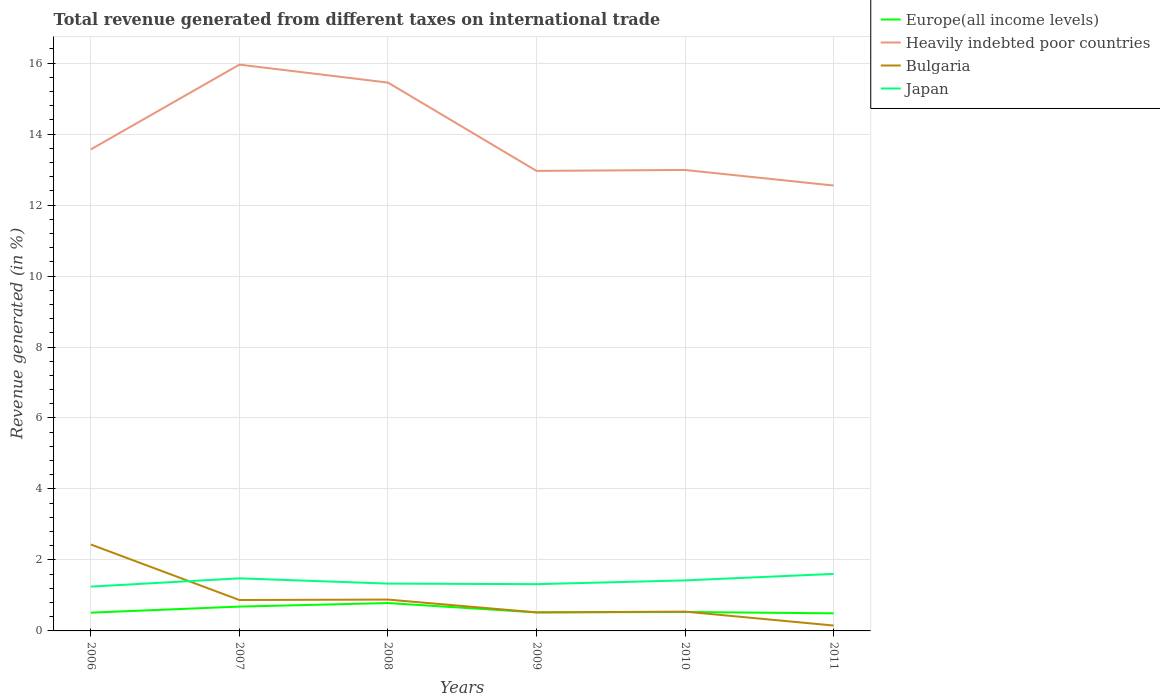Does the line corresponding to Heavily indebted poor countries intersect with the line corresponding to Japan?
Make the answer very short. No. Is the number of lines equal to the number of legend labels?
Offer a very short reply. Yes. Across all years, what is the maximum total revenue generated in Bulgaria?
Your response must be concise. 0.15. In which year was the total revenue generated in Europe(all income levels) maximum?
Provide a short and direct response. 2011. What is the total total revenue generated in Japan in the graph?
Offer a very short reply. -0.29. What is the difference between the highest and the second highest total revenue generated in Heavily indebted poor countries?
Ensure brevity in your answer.  3.41. How many lines are there?
Give a very brief answer. 4. What is the difference between two consecutive major ticks on the Y-axis?
Ensure brevity in your answer.  2. Does the graph contain grids?
Your answer should be very brief. Yes. How many legend labels are there?
Keep it short and to the point. 4. What is the title of the graph?
Provide a succinct answer. Total revenue generated from different taxes on international trade. What is the label or title of the X-axis?
Keep it short and to the point. Years. What is the label or title of the Y-axis?
Your answer should be compact. Revenue generated (in %). What is the Revenue generated (in %) of Europe(all income levels) in 2006?
Provide a short and direct response. 0.51. What is the Revenue generated (in %) in Heavily indebted poor countries in 2006?
Give a very brief answer. 13.57. What is the Revenue generated (in %) in Bulgaria in 2006?
Provide a succinct answer. 2.44. What is the Revenue generated (in %) of Japan in 2006?
Make the answer very short. 1.25. What is the Revenue generated (in %) in Europe(all income levels) in 2007?
Your answer should be compact. 0.69. What is the Revenue generated (in %) in Heavily indebted poor countries in 2007?
Keep it short and to the point. 15.96. What is the Revenue generated (in %) in Bulgaria in 2007?
Give a very brief answer. 0.87. What is the Revenue generated (in %) of Japan in 2007?
Offer a terse response. 1.48. What is the Revenue generated (in %) in Europe(all income levels) in 2008?
Make the answer very short. 0.79. What is the Revenue generated (in %) in Heavily indebted poor countries in 2008?
Your answer should be compact. 15.45. What is the Revenue generated (in %) of Bulgaria in 2008?
Offer a very short reply. 0.88. What is the Revenue generated (in %) of Japan in 2008?
Your response must be concise. 1.33. What is the Revenue generated (in %) of Europe(all income levels) in 2009?
Offer a very short reply. 0.52. What is the Revenue generated (in %) in Heavily indebted poor countries in 2009?
Your response must be concise. 12.96. What is the Revenue generated (in %) of Bulgaria in 2009?
Your answer should be very brief. 0.52. What is the Revenue generated (in %) in Japan in 2009?
Offer a terse response. 1.32. What is the Revenue generated (in %) in Europe(all income levels) in 2010?
Offer a very short reply. 0.53. What is the Revenue generated (in %) of Heavily indebted poor countries in 2010?
Offer a very short reply. 12.99. What is the Revenue generated (in %) in Bulgaria in 2010?
Offer a very short reply. 0.54. What is the Revenue generated (in %) of Japan in 2010?
Give a very brief answer. 1.42. What is the Revenue generated (in %) in Europe(all income levels) in 2011?
Offer a very short reply. 0.5. What is the Revenue generated (in %) in Heavily indebted poor countries in 2011?
Offer a terse response. 12.55. What is the Revenue generated (in %) in Bulgaria in 2011?
Make the answer very short. 0.15. What is the Revenue generated (in %) of Japan in 2011?
Your answer should be compact. 1.61. Across all years, what is the maximum Revenue generated (in %) of Europe(all income levels)?
Offer a very short reply. 0.79. Across all years, what is the maximum Revenue generated (in %) in Heavily indebted poor countries?
Provide a short and direct response. 15.96. Across all years, what is the maximum Revenue generated (in %) of Bulgaria?
Provide a short and direct response. 2.44. Across all years, what is the maximum Revenue generated (in %) of Japan?
Offer a very short reply. 1.61. Across all years, what is the minimum Revenue generated (in %) of Europe(all income levels)?
Offer a terse response. 0.5. Across all years, what is the minimum Revenue generated (in %) of Heavily indebted poor countries?
Your answer should be very brief. 12.55. Across all years, what is the minimum Revenue generated (in %) in Bulgaria?
Keep it short and to the point. 0.15. Across all years, what is the minimum Revenue generated (in %) of Japan?
Your answer should be very brief. 1.25. What is the total Revenue generated (in %) in Europe(all income levels) in the graph?
Keep it short and to the point. 3.54. What is the total Revenue generated (in %) in Heavily indebted poor countries in the graph?
Your response must be concise. 83.48. What is the total Revenue generated (in %) in Bulgaria in the graph?
Your answer should be very brief. 5.41. What is the total Revenue generated (in %) of Japan in the graph?
Offer a very short reply. 8.41. What is the difference between the Revenue generated (in %) of Europe(all income levels) in 2006 and that in 2007?
Offer a terse response. -0.17. What is the difference between the Revenue generated (in %) of Heavily indebted poor countries in 2006 and that in 2007?
Ensure brevity in your answer.  -2.39. What is the difference between the Revenue generated (in %) of Bulgaria in 2006 and that in 2007?
Ensure brevity in your answer.  1.56. What is the difference between the Revenue generated (in %) of Japan in 2006 and that in 2007?
Ensure brevity in your answer.  -0.23. What is the difference between the Revenue generated (in %) in Europe(all income levels) in 2006 and that in 2008?
Offer a terse response. -0.27. What is the difference between the Revenue generated (in %) of Heavily indebted poor countries in 2006 and that in 2008?
Make the answer very short. -1.88. What is the difference between the Revenue generated (in %) in Bulgaria in 2006 and that in 2008?
Your answer should be compact. 1.55. What is the difference between the Revenue generated (in %) in Japan in 2006 and that in 2008?
Offer a very short reply. -0.09. What is the difference between the Revenue generated (in %) of Europe(all income levels) in 2006 and that in 2009?
Provide a short and direct response. -0.01. What is the difference between the Revenue generated (in %) in Heavily indebted poor countries in 2006 and that in 2009?
Give a very brief answer. 0.61. What is the difference between the Revenue generated (in %) of Bulgaria in 2006 and that in 2009?
Make the answer very short. 1.91. What is the difference between the Revenue generated (in %) in Japan in 2006 and that in 2009?
Keep it short and to the point. -0.07. What is the difference between the Revenue generated (in %) in Europe(all income levels) in 2006 and that in 2010?
Your response must be concise. -0.02. What is the difference between the Revenue generated (in %) of Heavily indebted poor countries in 2006 and that in 2010?
Give a very brief answer. 0.58. What is the difference between the Revenue generated (in %) in Bulgaria in 2006 and that in 2010?
Offer a terse response. 1.89. What is the difference between the Revenue generated (in %) in Japan in 2006 and that in 2010?
Your answer should be compact. -0.18. What is the difference between the Revenue generated (in %) of Europe(all income levels) in 2006 and that in 2011?
Your response must be concise. 0.02. What is the difference between the Revenue generated (in %) of Heavily indebted poor countries in 2006 and that in 2011?
Provide a succinct answer. 1.02. What is the difference between the Revenue generated (in %) of Bulgaria in 2006 and that in 2011?
Ensure brevity in your answer.  2.28. What is the difference between the Revenue generated (in %) in Japan in 2006 and that in 2011?
Make the answer very short. -0.36. What is the difference between the Revenue generated (in %) in Europe(all income levels) in 2007 and that in 2008?
Provide a succinct answer. -0.1. What is the difference between the Revenue generated (in %) in Heavily indebted poor countries in 2007 and that in 2008?
Provide a succinct answer. 0.51. What is the difference between the Revenue generated (in %) of Bulgaria in 2007 and that in 2008?
Give a very brief answer. -0.01. What is the difference between the Revenue generated (in %) in Japan in 2007 and that in 2008?
Provide a short and direct response. 0.15. What is the difference between the Revenue generated (in %) in Europe(all income levels) in 2007 and that in 2009?
Give a very brief answer. 0.16. What is the difference between the Revenue generated (in %) of Heavily indebted poor countries in 2007 and that in 2009?
Provide a short and direct response. 2.99. What is the difference between the Revenue generated (in %) in Bulgaria in 2007 and that in 2009?
Your response must be concise. 0.35. What is the difference between the Revenue generated (in %) of Japan in 2007 and that in 2009?
Give a very brief answer. 0.16. What is the difference between the Revenue generated (in %) of Europe(all income levels) in 2007 and that in 2010?
Ensure brevity in your answer.  0.15. What is the difference between the Revenue generated (in %) of Heavily indebted poor countries in 2007 and that in 2010?
Your response must be concise. 2.97. What is the difference between the Revenue generated (in %) of Bulgaria in 2007 and that in 2010?
Offer a terse response. 0.33. What is the difference between the Revenue generated (in %) in Japan in 2007 and that in 2010?
Ensure brevity in your answer.  0.06. What is the difference between the Revenue generated (in %) of Europe(all income levels) in 2007 and that in 2011?
Your answer should be very brief. 0.19. What is the difference between the Revenue generated (in %) of Heavily indebted poor countries in 2007 and that in 2011?
Make the answer very short. 3.41. What is the difference between the Revenue generated (in %) in Bulgaria in 2007 and that in 2011?
Your answer should be very brief. 0.72. What is the difference between the Revenue generated (in %) of Japan in 2007 and that in 2011?
Offer a very short reply. -0.12. What is the difference between the Revenue generated (in %) of Europe(all income levels) in 2008 and that in 2009?
Give a very brief answer. 0.26. What is the difference between the Revenue generated (in %) in Heavily indebted poor countries in 2008 and that in 2009?
Give a very brief answer. 2.49. What is the difference between the Revenue generated (in %) in Bulgaria in 2008 and that in 2009?
Your response must be concise. 0.36. What is the difference between the Revenue generated (in %) in Japan in 2008 and that in 2009?
Your response must be concise. 0.02. What is the difference between the Revenue generated (in %) of Europe(all income levels) in 2008 and that in 2010?
Your answer should be compact. 0.25. What is the difference between the Revenue generated (in %) of Heavily indebted poor countries in 2008 and that in 2010?
Provide a short and direct response. 2.46. What is the difference between the Revenue generated (in %) in Bulgaria in 2008 and that in 2010?
Ensure brevity in your answer.  0.34. What is the difference between the Revenue generated (in %) in Japan in 2008 and that in 2010?
Provide a succinct answer. -0.09. What is the difference between the Revenue generated (in %) of Europe(all income levels) in 2008 and that in 2011?
Provide a short and direct response. 0.29. What is the difference between the Revenue generated (in %) of Heavily indebted poor countries in 2008 and that in 2011?
Your answer should be compact. 2.9. What is the difference between the Revenue generated (in %) of Bulgaria in 2008 and that in 2011?
Give a very brief answer. 0.73. What is the difference between the Revenue generated (in %) of Japan in 2008 and that in 2011?
Provide a short and direct response. -0.27. What is the difference between the Revenue generated (in %) in Europe(all income levels) in 2009 and that in 2010?
Give a very brief answer. -0.01. What is the difference between the Revenue generated (in %) of Heavily indebted poor countries in 2009 and that in 2010?
Provide a short and direct response. -0.03. What is the difference between the Revenue generated (in %) of Bulgaria in 2009 and that in 2010?
Offer a terse response. -0.02. What is the difference between the Revenue generated (in %) in Japan in 2009 and that in 2010?
Your answer should be very brief. -0.11. What is the difference between the Revenue generated (in %) of Europe(all income levels) in 2009 and that in 2011?
Your response must be concise. 0.03. What is the difference between the Revenue generated (in %) of Heavily indebted poor countries in 2009 and that in 2011?
Keep it short and to the point. 0.41. What is the difference between the Revenue generated (in %) of Bulgaria in 2009 and that in 2011?
Provide a succinct answer. 0.37. What is the difference between the Revenue generated (in %) of Japan in 2009 and that in 2011?
Ensure brevity in your answer.  -0.29. What is the difference between the Revenue generated (in %) in Europe(all income levels) in 2010 and that in 2011?
Your answer should be compact. 0.04. What is the difference between the Revenue generated (in %) of Heavily indebted poor countries in 2010 and that in 2011?
Offer a very short reply. 0.44. What is the difference between the Revenue generated (in %) of Bulgaria in 2010 and that in 2011?
Make the answer very short. 0.39. What is the difference between the Revenue generated (in %) of Japan in 2010 and that in 2011?
Your answer should be compact. -0.18. What is the difference between the Revenue generated (in %) of Europe(all income levels) in 2006 and the Revenue generated (in %) of Heavily indebted poor countries in 2007?
Make the answer very short. -15.44. What is the difference between the Revenue generated (in %) in Europe(all income levels) in 2006 and the Revenue generated (in %) in Bulgaria in 2007?
Give a very brief answer. -0.36. What is the difference between the Revenue generated (in %) of Europe(all income levels) in 2006 and the Revenue generated (in %) of Japan in 2007?
Provide a short and direct response. -0.97. What is the difference between the Revenue generated (in %) in Heavily indebted poor countries in 2006 and the Revenue generated (in %) in Bulgaria in 2007?
Offer a very short reply. 12.7. What is the difference between the Revenue generated (in %) of Heavily indebted poor countries in 2006 and the Revenue generated (in %) of Japan in 2007?
Make the answer very short. 12.09. What is the difference between the Revenue generated (in %) of Bulgaria in 2006 and the Revenue generated (in %) of Japan in 2007?
Make the answer very short. 0.95. What is the difference between the Revenue generated (in %) in Europe(all income levels) in 2006 and the Revenue generated (in %) in Heavily indebted poor countries in 2008?
Offer a very short reply. -14.94. What is the difference between the Revenue generated (in %) in Europe(all income levels) in 2006 and the Revenue generated (in %) in Bulgaria in 2008?
Provide a succinct answer. -0.37. What is the difference between the Revenue generated (in %) in Europe(all income levels) in 2006 and the Revenue generated (in %) in Japan in 2008?
Ensure brevity in your answer.  -0.82. What is the difference between the Revenue generated (in %) in Heavily indebted poor countries in 2006 and the Revenue generated (in %) in Bulgaria in 2008?
Keep it short and to the point. 12.69. What is the difference between the Revenue generated (in %) of Heavily indebted poor countries in 2006 and the Revenue generated (in %) of Japan in 2008?
Provide a short and direct response. 12.23. What is the difference between the Revenue generated (in %) in Bulgaria in 2006 and the Revenue generated (in %) in Japan in 2008?
Ensure brevity in your answer.  1.1. What is the difference between the Revenue generated (in %) in Europe(all income levels) in 2006 and the Revenue generated (in %) in Heavily indebted poor countries in 2009?
Provide a succinct answer. -12.45. What is the difference between the Revenue generated (in %) in Europe(all income levels) in 2006 and the Revenue generated (in %) in Bulgaria in 2009?
Ensure brevity in your answer.  -0.01. What is the difference between the Revenue generated (in %) of Europe(all income levels) in 2006 and the Revenue generated (in %) of Japan in 2009?
Your answer should be compact. -0.8. What is the difference between the Revenue generated (in %) in Heavily indebted poor countries in 2006 and the Revenue generated (in %) in Bulgaria in 2009?
Give a very brief answer. 13.05. What is the difference between the Revenue generated (in %) in Heavily indebted poor countries in 2006 and the Revenue generated (in %) in Japan in 2009?
Offer a very short reply. 12.25. What is the difference between the Revenue generated (in %) of Bulgaria in 2006 and the Revenue generated (in %) of Japan in 2009?
Provide a short and direct response. 1.12. What is the difference between the Revenue generated (in %) of Europe(all income levels) in 2006 and the Revenue generated (in %) of Heavily indebted poor countries in 2010?
Offer a terse response. -12.47. What is the difference between the Revenue generated (in %) of Europe(all income levels) in 2006 and the Revenue generated (in %) of Bulgaria in 2010?
Your answer should be very brief. -0.03. What is the difference between the Revenue generated (in %) of Europe(all income levels) in 2006 and the Revenue generated (in %) of Japan in 2010?
Offer a very short reply. -0.91. What is the difference between the Revenue generated (in %) of Heavily indebted poor countries in 2006 and the Revenue generated (in %) of Bulgaria in 2010?
Keep it short and to the point. 13.02. What is the difference between the Revenue generated (in %) of Heavily indebted poor countries in 2006 and the Revenue generated (in %) of Japan in 2010?
Your answer should be compact. 12.14. What is the difference between the Revenue generated (in %) of Bulgaria in 2006 and the Revenue generated (in %) of Japan in 2010?
Provide a short and direct response. 1.01. What is the difference between the Revenue generated (in %) of Europe(all income levels) in 2006 and the Revenue generated (in %) of Heavily indebted poor countries in 2011?
Your answer should be compact. -12.04. What is the difference between the Revenue generated (in %) in Europe(all income levels) in 2006 and the Revenue generated (in %) in Bulgaria in 2011?
Give a very brief answer. 0.36. What is the difference between the Revenue generated (in %) of Europe(all income levels) in 2006 and the Revenue generated (in %) of Japan in 2011?
Make the answer very short. -1.09. What is the difference between the Revenue generated (in %) in Heavily indebted poor countries in 2006 and the Revenue generated (in %) in Bulgaria in 2011?
Offer a very short reply. 13.42. What is the difference between the Revenue generated (in %) in Heavily indebted poor countries in 2006 and the Revenue generated (in %) in Japan in 2011?
Provide a succinct answer. 11.96. What is the difference between the Revenue generated (in %) in Bulgaria in 2006 and the Revenue generated (in %) in Japan in 2011?
Offer a terse response. 0.83. What is the difference between the Revenue generated (in %) in Europe(all income levels) in 2007 and the Revenue generated (in %) in Heavily indebted poor countries in 2008?
Make the answer very short. -14.77. What is the difference between the Revenue generated (in %) of Europe(all income levels) in 2007 and the Revenue generated (in %) of Bulgaria in 2008?
Your response must be concise. -0.2. What is the difference between the Revenue generated (in %) of Europe(all income levels) in 2007 and the Revenue generated (in %) of Japan in 2008?
Provide a succinct answer. -0.65. What is the difference between the Revenue generated (in %) of Heavily indebted poor countries in 2007 and the Revenue generated (in %) of Bulgaria in 2008?
Give a very brief answer. 15.07. What is the difference between the Revenue generated (in %) in Heavily indebted poor countries in 2007 and the Revenue generated (in %) in Japan in 2008?
Ensure brevity in your answer.  14.62. What is the difference between the Revenue generated (in %) of Bulgaria in 2007 and the Revenue generated (in %) of Japan in 2008?
Offer a very short reply. -0.46. What is the difference between the Revenue generated (in %) in Europe(all income levels) in 2007 and the Revenue generated (in %) in Heavily indebted poor countries in 2009?
Your answer should be compact. -12.28. What is the difference between the Revenue generated (in %) in Europe(all income levels) in 2007 and the Revenue generated (in %) in Bulgaria in 2009?
Offer a terse response. 0.16. What is the difference between the Revenue generated (in %) in Europe(all income levels) in 2007 and the Revenue generated (in %) in Japan in 2009?
Ensure brevity in your answer.  -0.63. What is the difference between the Revenue generated (in %) in Heavily indebted poor countries in 2007 and the Revenue generated (in %) in Bulgaria in 2009?
Your response must be concise. 15.43. What is the difference between the Revenue generated (in %) of Heavily indebted poor countries in 2007 and the Revenue generated (in %) of Japan in 2009?
Provide a succinct answer. 14.64. What is the difference between the Revenue generated (in %) of Bulgaria in 2007 and the Revenue generated (in %) of Japan in 2009?
Your answer should be very brief. -0.45. What is the difference between the Revenue generated (in %) of Europe(all income levels) in 2007 and the Revenue generated (in %) of Heavily indebted poor countries in 2010?
Offer a very short reply. -12.3. What is the difference between the Revenue generated (in %) of Europe(all income levels) in 2007 and the Revenue generated (in %) of Bulgaria in 2010?
Your answer should be very brief. 0.14. What is the difference between the Revenue generated (in %) of Europe(all income levels) in 2007 and the Revenue generated (in %) of Japan in 2010?
Your response must be concise. -0.74. What is the difference between the Revenue generated (in %) of Heavily indebted poor countries in 2007 and the Revenue generated (in %) of Bulgaria in 2010?
Give a very brief answer. 15.41. What is the difference between the Revenue generated (in %) in Heavily indebted poor countries in 2007 and the Revenue generated (in %) in Japan in 2010?
Your answer should be very brief. 14.53. What is the difference between the Revenue generated (in %) of Bulgaria in 2007 and the Revenue generated (in %) of Japan in 2010?
Make the answer very short. -0.55. What is the difference between the Revenue generated (in %) in Europe(all income levels) in 2007 and the Revenue generated (in %) in Heavily indebted poor countries in 2011?
Offer a terse response. -11.86. What is the difference between the Revenue generated (in %) of Europe(all income levels) in 2007 and the Revenue generated (in %) of Bulgaria in 2011?
Your response must be concise. 0.53. What is the difference between the Revenue generated (in %) of Europe(all income levels) in 2007 and the Revenue generated (in %) of Japan in 2011?
Give a very brief answer. -0.92. What is the difference between the Revenue generated (in %) in Heavily indebted poor countries in 2007 and the Revenue generated (in %) in Bulgaria in 2011?
Make the answer very short. 15.81. What is the difference between the Revenue generated (in %) in Heavily indebted poor countries in 2007 and the Revenue generated (in %) in Japan in 2011?
Offer a very short reply. 14.35. What is the difference between the Revenue generated (in %) of Bulgaria in 2007 and the Revenue generated (in %) of Japan in 2011?
Your answer should be very brief. -0.74. What is the difference between the Revenue generated (in %) of Europe(all income levels) in 2008 and the Revenue generated (in %) of Heavily indebted poor countries in 2009?
Make the answer very short. -12.18. What is the difference between the Revenue generated (in %) of Europe(all income levels) in 2008 and the Revenue generated (in %) of Bulgaria in 2009?
Make the answer very short. 0.26. What is the difference between the Revenue generated (in %) of Europe(all income levels) in 2008 and the Revenue generated (in %) of Japan in 2009?
Your answer should be compact. -0.53. What is the difference between the Revenue generated (in %) of Heavily indebted poor countries in 2008 and the Revenue generated (in %) of Bulgaria in 2009?
Your answer should be compact. 14.93. What is the difference between the Revenue generated (in %) in Heavily indebted poor countries in 2008 and the Revenue generated (in %) in Japan in 2009?
Provide a succinct answer. 14.13. What is the difference between the Revenue generated (in %) of Bulgaria in 2008 and the Revenue generated (in %) of Japan in 2009?
Offer a very short reply. -0.43. What is the difference between the Revenue generated (in %) in Europe(all income levels) in 2008 and the Revenue generated (in %) in Heavily indebted poor countries in 2010?
Ensure brevity in your answer.  -12.2. What is the difference between the Revenue generated (in %) in Europe(all income levels) in 2008 and the Revenue generated (in %) in Bulgaria in 2010?
Your response must be concise. 0.24. What is the difference between the Revenue generated (in %) of Europe(all income levels) in 2008 and the Revenue generated (in %) of Japan in 2010?
Your answer should be very brief. -0.64. What is the difference between the Revenue generated (in %) of Heavily indebted poor countries in 2008 and the Revenue generated (in %) of Bulgaria in 2010?
Give a very brief answer. 14.91. What is the difference between the Revenue generated (in %) of Heavily indebted poor countries in 2008 and the Revenue generated (in %) of Japan in 2010?
Give a very brief answer. 14.03. What is the difference between the Revenue generated (in %) of Bulgaria in 2008 and the Revenue generated (in %) of Japan in 2010?
Keep it short and to the point. -0.54. What is the difference between the Revenue generated (in %) in Europe(all income levels) in 2008 and the Revenue generated (in %) in Heavily indebted poor countries in 2011?
Provide a succinct answer. -11.76. What is the difference between the Revenue generated (in %) of Europe(all income levels) in 2008 and the Revenue generated (in %) of Bulgaria in 2011?
Keep it short and to the point. 0.63. What is the difference between the Revenue generated (in %) in Europe(all income levels) in 2008 and the Revenue generated (in %) in Japan in 2011?
Keep it short and to the point. -0.82. What is the difference between the Revenue generated (in %) in Heavily indebted poor countries in 2008 and the Revenue generated (in %) in Bulgaria in 2011?
Make the answer very short. 15.3. What is the difference between the Revenue generated (in %) in Heavily indebted poor countries in 2008 and the Revenue generated (in %) in Japan in 2011?
Your answer should be very brief. 13.84. What is the difference between the Revenue generated (in %) of Bulgaria in 2008 and the Revenue generated (in %) of Japan in 2011?
Your response must be concise. -0.72. What is the difference between the Revenue generated (in %) in Europe(all income levels) in 2009 and the Revenue generated (in %) in Heavily indebted poor countries in 2010?
Your answer should be very brief. -12.47. What is the difference between the Revenue generated (in %) of Europe(all income levels) in 2009 and the Revenue generated (in %) of Bulgaria in 2010?
Your response must be concise. -0.02. What is the difference between the Revenue generated (in %) in Europe(all income levels) in 2009 and the Revenue generated (in %) in Japan in 2010?
Offer a very short reply. -0.9. What is the difference between the Revenue generated (in %) in Heavily indebted poor countries in 2009 and the Revenue generated (in %) in Bulgaria in 2010?
Keep it short and to the point. 12.42. What is the difference between the Revenue generated (in %) in Heavily indebted poor countries in 2009 and the Revenue generated (in %) in Japan in 2010?
Offer a terse response. 11.54. What is the difference between the Revenue generated (in %) in Bulgaria in 2009 and the Revenue generated (in %) in Japan in 2010?
Your answer should be compact. -0.9. What is the difference between the Revenue generated (in %) of Europe(all income levels) in 2009 and the Revenue generated (in %) of Heavily indebted poor countries in 2011?
Ensure brevity in your answer.  -12.03. What is the difference between the Revenue generated (in %) in Europe(all income levels) in 2009 and the Revenue generated (in %) in Bulgaria in 2011?
Give a very brief answer. 0.37. What is the difference between the Revenue generated (in %) in Europe(all income levels) in 2009 and the Revenue generated (in %) in Japan in 2011?
Ensure brevity in your answer.  -1.08. What is the difference between the Revenue generated (in %) in Heavily indebted poor countries in 2009 and the Revenue generated (in %) in Bulgaria in 2011?
Provide a succinct answer. 12.81. What is the difference between the Revenue generated (in %) in Heavily indebted poor countries in 2009 and the Revenue generated (in %) in Japan in 2011?
Keep it short and to the point. 11.36. What is the difference between the Revenue generated (in %) in Bulgaria in 2009 and the Revenue generated (in %) in Japan in 2011?
Your answer should be very brief. -1.08. What is the difference between the Revenue generated (in %) of Europe(all income levels) in 2010 and the Revenue generated (in %) of Heavily indebted poor countries in 2011?
Your response must be concise. -12.02. What is the difference between the Revenue generated (in %) in Europe(all income levels) in 2010 and the Revenue generated (in %) in Bulgaria in 2011?
Make the answer very short. 0.38. What is the difference between the Revenue generated (in %) of Europe(all income levels) in 2010 and the Revenue generated (in %) of Japan in 2011?
Offer a very short reply. -1.07. What is the difference between the Revenue generated (in %) in Heavily indebted poor countries in 2010 and the Revenue generated (in %) in Bulgaria in 2011?
Give a very brief answer. 12.84. What is the difference between the Revenue generated (in %) of Heavily indebted poor countries in 2010 and the Revenue generated (in %) of Japan in 2011?
Keep it short and to the point. 11.38. What is the difference between the Revenue generated (in %) of Bulgaria in 2010 and the Revenue generated (in %) of Japan in 2011?
Offer a terse response. -1.06. What is the average Revenue generated (in %) of Europe(all income levels) per year?
Provide a succinct answer. 0.59. What is the average Revenue generated (in %) of Heavily indebted poor countries per year?
Provide a short and direct response. 13.91. What is the average Revenue generated (in %) of Bulgaria per year?
Offer a very short reply. 0.9. What is the average Revenue generated (in %) in Japan per year?
Your response must be concise. 1.4. In the year 2006, what is the difference between the Revenue generated (in %) of Europe(all income levels) and Revenue generated (in %) of Heavily indebted poor countries?
Offer a terse response. -13.05. In the year 2006, what is the difference between the Revenue generated (in %) of Europe(all income levels) and Revenue generated (in %) of Bulgaria?
Give a very brief answer. -1.92. In the year 2006, what is the difference between the Revenue generated (in %) of Europe(all income levels) and Revenue generated (in %) of Japan?
Keep it short and to the point. -0.73. In the year 2006, what is the difference between the Revenue generated (in %) in Heavily indebted poor countries and Revenue generated (in %) in Bulgaria?
Provide a short and direct response. 11.13. In the year 2006, what is the difference between the Revenue generated (in %) of Heavily indebted poor countries and Revenue generated (in %) of Japan?
Your answer should be compact. 12.32. In the year 2006, what is the difference between the Revenue generated (in %) in Bulgaria and Revenue generated (in %) in Japan?
Ensure brevity in your answer.  1.19. In the year 2007, what is the difference between the Revenue generated (in %) of Europe(all income levels) and Revenue generated (in %) of Heavily indebted poor countries?
Give a very brief answer. -15.27. In the year 2007, what is the difference between the Revenue generated (in %) of Europe(all income levels) and Revenue generated (in %) of Bulgaria?
Keep it short and to the point. -0.19. In the year 2007, what is the difference between the Revenue generated (in %) of Europe(all income levels) and Revenue generated (in %) of Japan?
Ensure brevity in your answer.  -0.8. In the year 2007, what is the difference between the Revenue generated (in %) in Heavily indebted poor countries and Revenue generated (in %) in Bulgaria?
Your response must be concise. 15.09. In the year 2007, what is the difference between the Revenue generated (in %) of Heavily indebted poor countries and Revenue generated (in %) of Japan?
Your answer should be compact. 14.48. In the year 2007, what is the difference between the Revenue generated (in %) of Bulgaria and Revenue generated (in %) of Japan?
Give a very brief answer. -0.61. In the year 2008, what is the difference between the Revenue generated (in %) of Europe(all income levels) and Revenue generated (in %) of Heavily indebted poor countries?
Offer a very short reply. -14.67. In the year 2008, what is the difference between the Revenue generated (in %) of Europe(all income levels) and Revenue generated (in %) of Bulgaria?
Make the answer very short. -0.1. In the year 2008, what is the difference between the Revenue generated (in %) in Europe(all income levels) and Revenue generated (in %) in Japan?
Provide a short and direct response. -0.55. In the year 2008, what is the difference between the Revenue generated (in %) in Heavily indebted poor countries and Revenue generated (in %) in Bulgaria?
Make the answer very short. 14.57. In the year 2008, what is the difference between the Revenue generated (in %) in Heavily indebted poor countries and Revenue generated (in %) in Japan?
Keep it short and to the point. 14.12. In the year 2008, what is the difference between the Revenue generated (in %) in Bulgaria and Revenue generated (in %) in Japan?
Provide a short and direct response. -0.45. In the year 2009, what is the difference between the Revenue generated (in %) in Europe(all income levels) and Revenue generated (in %) in Heavily indebted poor countries?
Provide a short and direct response. -12.44. In the year 2009, what is the difference between the Revenue generated (in %) of Europe(all income levels) and Revenue generated (in %) of Bulgaria?
Give a very brief answer. 0. In the year 2009, what is the difference between the Revenue generated (in %) of Europe(all income levels) and Revenue generated (in %) of Japan?
Your answer should be compact. -0.8. In the year 2009, what is the difference between the Revenue generated (in %) of Heavily indebted poor countries and Revenue generated (in %) of Bulgaria?
Give a very brief answer. 12.44. In the year 2009, what is the difference between the Revenue generated (in %) in Heavily indebted poor countries and Revenue generated (in %) in Japan?
Offer a very short reply. 11.65. In the year 2009, what is the difference between the Revenue generated (in %) in Bulgaria and Revenue generated (in %) in Japan?
Provide a short and direct response. -0.8. In the year 2010, what is the difference between the Revenue generated (in %) in Europe(all income levels) and Revenue generated (in %) in Heavily indebted poor countries?
Your response must be concise. -12.45. In the year 2010, what is the difference between the Revenue generated (in %) of Europe(all income levels) and Revenue generated (in %) of Bulgaria?
Your answer should be compact. -0.01. In the year 2010, what is the difference between the Revenue generated (in %) of Europe(all income levels) and Revenue generated (in %) of Japan?
Make the answer very short. -0.89. In the year 2010, what is the difference between the Revenue generated (in %) in Heavily indebted poor countries and Revenue generated (in %) in Bulgaria?
Your answer should be very brief. 12.45. In the year 2010, what is the difference between the Revenue generated (in %) in Heavily indebted poor countries and Revenue generated (in %) in Japan?
Offer a very short reply. 11.56. In the year 2010, what is the difference between the Revenue generated (in %) of Bulgaria and Revenue generated (in %) of Japan?
Keep it short and to the point. -0.88. In the year 2011, what is the difference between the Revenue generated (in %) of Europe(all income levels) and Revenue generated (in %) of Heavily indebted poor countries?
Your response must be concise. -12.05. In the year 2011, what is the difference between the Revenue generated (in %) of Europe(all income levels) and Revenue generated (in %) of Bulgaria?
Provide a succinct answer. 0.34. In the year 2011, what is the difference between the Revenue generated (in %) in Europe(all income levels) and Revenue generated (in %) in Japan?
Provide a short and direct response. -1.11. In the year 2011, what is the difference between the Revenue generated (in %) in Heavily indebted poor countries and Revenue generated (in %) in Bulgaria?
Your answer should be compact. 12.4. In the year 2011, what is the difference between the Revenue generated (in %) of Heavily indebted poor countries and Revenue generated (in %) of Japan?
Provide a short and direct response. 10.94. In the year 2011, what is the difference between the Revenue generated (in %) of Bulgaria and Revenue generated (in %) of Japan?
Provide a short and direct response. -1.45. What is the ratio of the Revenue generated (in %) of Europe(all income levels) in 2006 to that in 2007?
Your answer should be very brief. 0.75. What is the ratio of the Revenue generated (in %) in Heavily indebted poor countries in 2006 to that in 2007?
Ensure brevity in your answer.  0.85. What is the ratio of the Revenue generated (in %) of Bulgaria in 2006 to that in 2007?
Keep it short and to the point. 2.8. What is the ratio of the Revenue generated (in %) in Japan in 2006 to that in 2007?
Provide a short and direct response. 0.84. What is the ratio of the Revenue generated (in %) of Europe(all income levels) in 2006 to that in 2008?
Your answer should be compact. 0.66. What is the ratio of the Revenue generated (in %) of Heavily indebted poor countries in 2006 to that in 2008?
Offer a very short reply. 0.88. What is the ratio of the Revenue generated (in %) in Bulgaria in 2006 to that in 2008?
Make the answer very short. 2.76. What is the ratio of the Revenue generated (in %) in Japan in 2006 to that in 2008?
Offer a terse response. 0.94. What is the ratio of the Revenue generated (in %) in Europe(all income levels) in 2006 to that in 2009?
Give a very brief answer. 0.99. What is the ratio of the Revenue generated (in %) in Heavily indebted poor countries in 2006 to that in 2009?
Your response must be concise. 1.05. What is the ratio of the Revenue generated (in %) of Bulgaria in 2006 to that in 2009?
Your answer should be very brief. 4.66. What is the ratio of the Revenue generated (in %) in Japan in 2006 to that in 2009?
Keep it short and to the point. 0.95. What is the ratio of the Revenue generated (in %) of Heavily indebted poor countries in 2006 to that in 2010?
Your answer should be very brief. 1.04. What is the ratio of the Revenue generated (in %) of Bulgaria in 2006 to that in 2010?
Offer a very short reply. 4.48. What is the ratio of the Revenue generated (in %) in Japan in 2006 to that in 2010?
Your answer should be compact. 0.88. What is the ratio of the Revenue generated (in %) of Europe(all income levels) in 2006 to that in 2011?
Make the answer very short. 1.04. What is the ratio of the Revenue generated (in %) of Heavily indebted poor countries in 2006 to that in 2011?
Your answer should be compact. 1.08. What is the ratio of the Revenue generated (in %) in Bulgaria in 2006 to that in 2011?
Make the answer very short. 16.04. What is the ratio of the Revenue generated (in %) in Japan in 2006 to that in 2011?
Provide a succinct answer. 0.78. What is the ratio of the Revenue generated (in %) of Europe(all income levels) in 2007 to that in 2008?
Offer a terse response. 0.87. What is the ratio of the Revenue generated (in %) of Heavily indebted poor countries in 2007 to that in 2008?
Ensure brevity in your answer.  1.03. What is the ratio of the Revenue generated (in %) of Bulgaria in 2007 to that in 2008?
Give a very brief answer. 0.99. What is the ratio of the Revenue generated (in %) of Japan in 2007 to that in 2008?
Your answer should be very brief. 1.11. What is the ratio of the Revenue generated (in %) in Europe(all income levels) in 2007 to that in 2009?
Offer a very short reply. 1.31. What is the ratio of the Revenue generated (in %) of Heavily indebted poor countries in 2007 to that in 2009?
Your answer should be very brief. 1.23. What is the ratio of the Revenue generated (in %) in Bulgaria in 2007 to that in 2009?
Offer a terse response. 1.67. What is the ratio of the Revenue generated (in %) of Japan in 2007 to that in 2009?
Offer a very short reply. 1.12. What is the ratio of the Revenue generated (in %) in Europe(all income levels) in 2007 to that in 2010?
Offer a very short reply. 1.28. What is the ratio of the Revenue generated (in %) of Heavily indebted poor countries in 2007 to that in 2010?
Ensure brevity in your answer.  1.23. What is the ratio of the Revenue generated (in %) in Bulgaria in 2007 to that in 2010?
Offer a terse response. 1.6. What is the ratio of the Revenue generated (in %) of Japan in 2007 to that in 2010?
Provide a succinct answer. 1.04. What is the ratio of the Revenue generated (in %) in Europe(all income levels) in 2007 to that in 2011?
Offer a terse response. 1.38. What is the ratio of the Revenue generated (in %) of Heavily indebted poor countries in 2007 to that in 2011?
Your answer should be very brief. 1.27. What is the ratio of the Revenue generated (in %) in Bulgaria in 2007 to that in 2011?
Keep it short and to the point. 5.74. What is the ratio of the Revenue generated (in %) of Japan in 2007 to that in 2011?
Keep it short and to the point. 0.92. What is the ratio of the Revenue generated (in %) in Europe(all income levels) in 2008 to that in 2009?
Ensure brevity in your answer.  1.5. What is the ratio of the Revenue generated (in %) in Heavily indebted poor countries in 2008 to that in 2009?
Make the answer very short. 1.19. What is the ratio of the Revenue generated (in %) of Bulgaria in 2008 to that in 2009?
Ensure brevity in your answer.  1.69. What is the ratio of the Revenue generated (in %) in Japan in 2008 to that in 2009?
Your response must be concise. 1.01. What is the ratio of the Revenue generated (in %) in Europe(all income levels) in 2008 to that in 2010?
Provide a short and direct response. 1.47. What is the ratio of the Revenue generated (in %) in Heavily indebted poor countries in 2008 to that in 2010?
Your answer should be very brief. 1.19. What is the ratio of the Revenue generated (in %) of Bulgaria in 2008 to that in 2010?
Provide a short and direct response. 1.62. What is the ratio of the Revenue generated (in %) in Japan in 2008 to that in 2010?
Provide a succinct answer. 0.94. What is the ratio of the Revenue generated (in %) of Europe(all income levels) in 2008 to that in 2011?
Make the answer very short. 1.58. What is the ratio of the Revenue generated (in %) of Heavily indebted poor countries in 2008 to that in 2011?
Ensure brevity in your answer.  1.23. What is the ratio of the Revenue generated (in %) in Bulgaria in 2008 to that in 2011?
Your answer should be compact. 5.82. What is the ratio of the Revenue generated (in %) of Japan in 2008 to that in 2011?
Provide a succinct answer. 0.83. What is the ratio of the Revenue generated (in %) in Europe(all income levels) in 2009 to that in 2010?
Ensure brevity in your answer.  0.98. What is the ratio of the Revenue generated (in %) in Heavily indebted poor countries in 2009 to that in 2010?
Give a very brief answer. 1. What is the ratio of the Revenue generated (in %) of Bulgaria in 2009 to that in 2010?
Ensure brevity in your answer.  0.96. What is the ratio of the Revenue generated (in %) in Japan in 2009 to that in 2010?
Your answer should be very brief. 0.93. What is the ratio of the Revenue generated (in %) in Europe(all income levels) in 2009 to that in 2011?
Provide a succinct answer. 1.05. What is the ratio of the Revenue generated (in %) of Heavily indebted poor countries in 2009 to that in 2011?
Your answer should be very brief. 1.03. What is the ratio of the Revenue generated (in %) of Bulgaria in 2009 to that in 2011?
Your answer should be compact. 3.44. What is the ratio of the Revenue generated (in %) of Japan in 2009 to that in 2011?
Your answer should be very brief. 0.82. What is the ratio of the Revenue generated (in %) of Europe(all income levels) in 2010 to that in 2011?
Provide a short and direct response. 1.08. What is the ratio of the Revenue generated (in %) of Heavily indebted poor countries in 2010 to that in 2011?
Give a very brief answer. 1.03. What is the ratio of the Revenue generated (in %) of Bulgaria in 2010 to that in 2011?
Provide a short and direct response. 3.58. What is the ratio of the Revenue generated (in %) in Japan in 2010 to that in 2011?
Give a very brief answer. 0.89. What is the difference between the highest and the second highest Revenue generated (in %) of Europe(all income levels)?
Your response must be concise. 0.1. What is the difference between the highest and the second highest Revenue generated (in %) of Heavily indebted poor countries?
Ensure brevity in your answer.  0.51. What is the difference between the highest and the second highest Revenue generated (in %) in Bulgaria?
Offer a terse response. 1.55. What is the difference between the highest and the lowest Revenue generated (in %) in Europe(all income levels)?
Make the answer very short. 0.29. What is the difference between the highest and the lowest Revenue generated (in %) of Heavily indebted poor countries?
Offer a very short reply. 3.41. What is the difference between the highest and the lowest Revenue generated (in %) in Bulgaria?
Provide a short and direct response. 2.28. What is the difference between the highest and the lowest Revenue generated (in %) of Japan?
Give a very brief answer. 0.36. 